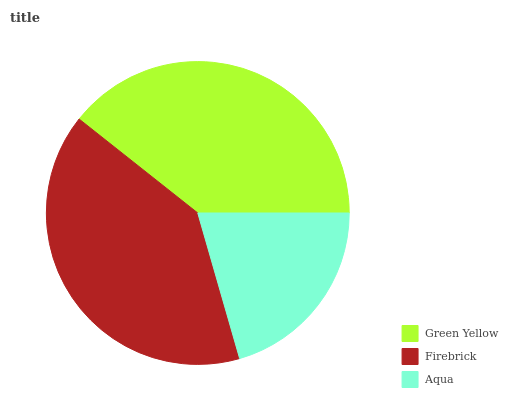Is Aqua the minimum?
Answer yes or no. Yes. Is Firebrick the maximum?
Answer yes or no. Yes. Is Firebrick the minimum?
Answer yes or no. No. Is Aqua the maximum?
Answer yes or no. No. Is Firebrick greater than Aqua?
Answer yes or no. Yes. Is Aqua less than Firebrick?
Answer yes or no. Yes. Is Aqua greater than Firebrick?
Answer yes or no. No. Is Firebrick less than Aqua?
Answer yes or no. No. Is Green Yellow the high median?
Answer yes or no. Yes. Is Green Yellow the low median?
Answer yes or no. Yes. Is Firebrick the high median?
Answer yes or no. No. Is Firebrick the low median?
Answer yes or no. No. 